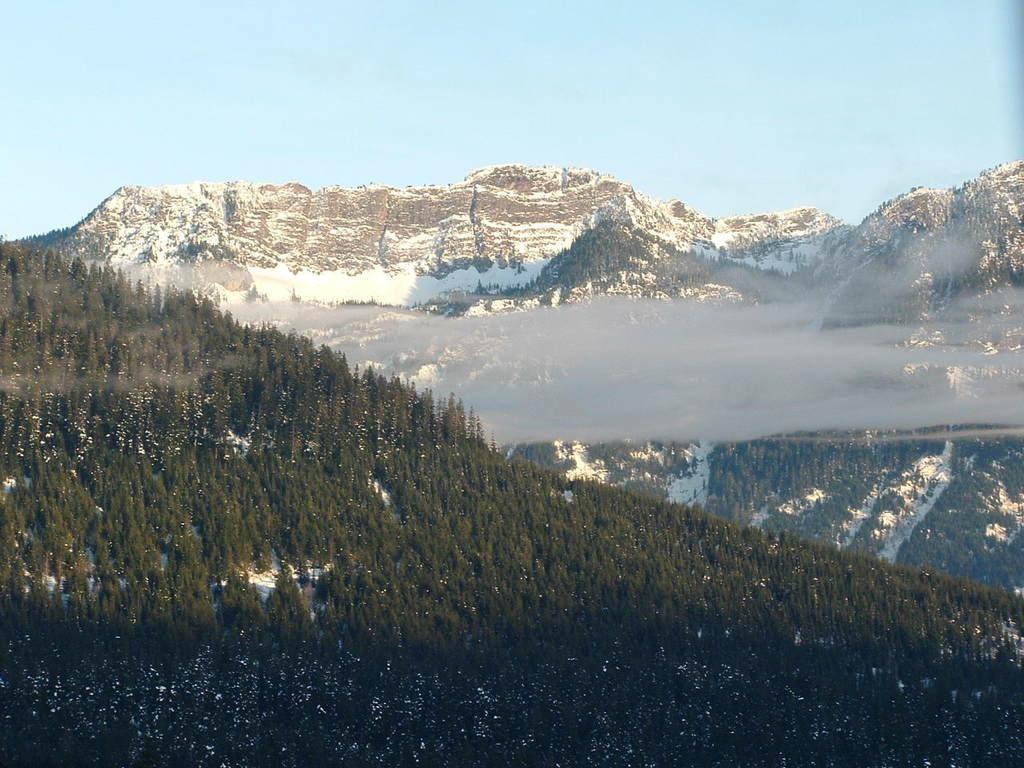Please provide a concise description of this image. In this picture there are few trees and the ground is covered with snow and there are few mountains covered with snow in the background. 